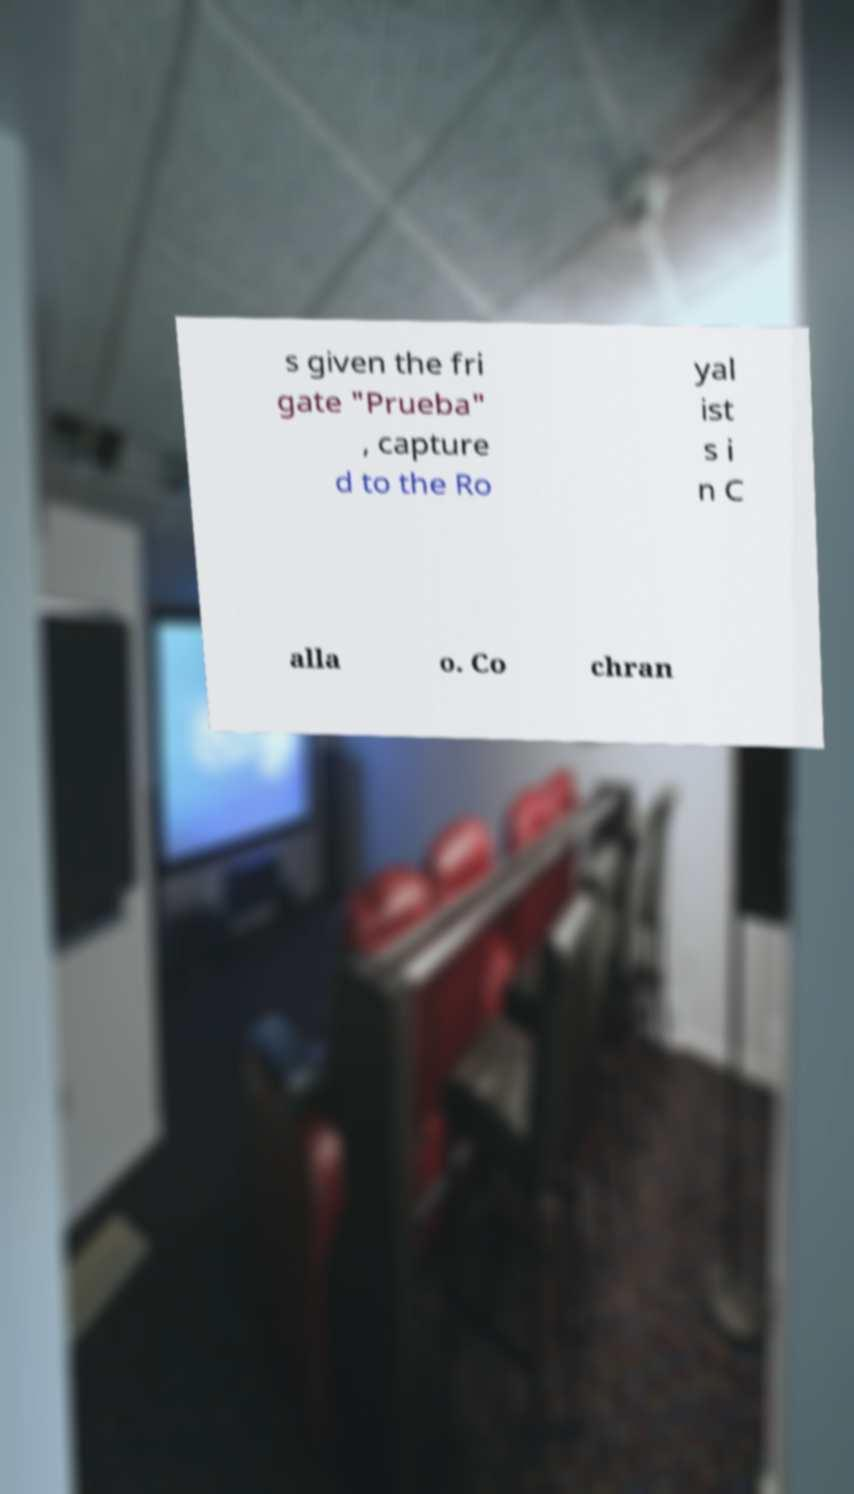I need the written content from this picture converted into text. Can you do that? s given the fri gate "Prueba" , capture d to the Ro yal ist s i n C alla o. Co chran 